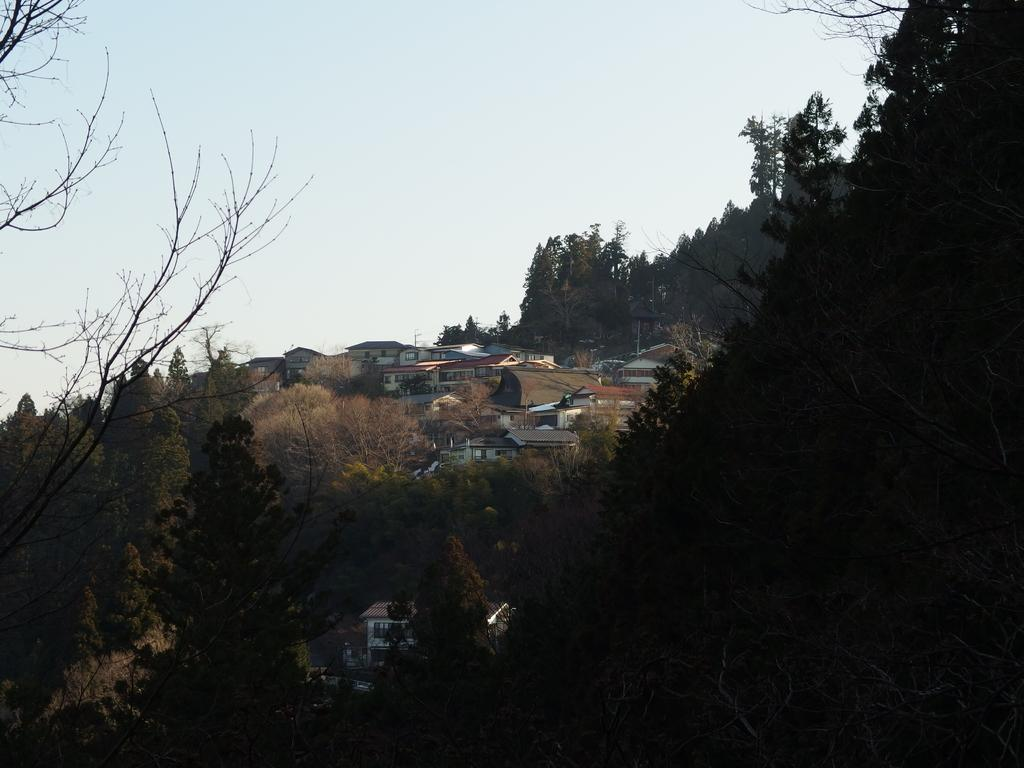What type of vegetation is at the bottom of the image? There are trees at the bottom of the image. What structures can be seen in the middle of the image? There are houses in the middle of the image. What is visible at the top of the image? The sky is visible at the top of the image. What title does the grandfather hold in the image? There is no grandfather present in the image, so there is no title to discuss. What trick is being performed by the trees at the bottom of the image? There is no trick being performed by the trees in the image; they are simply standing in their natural state. 